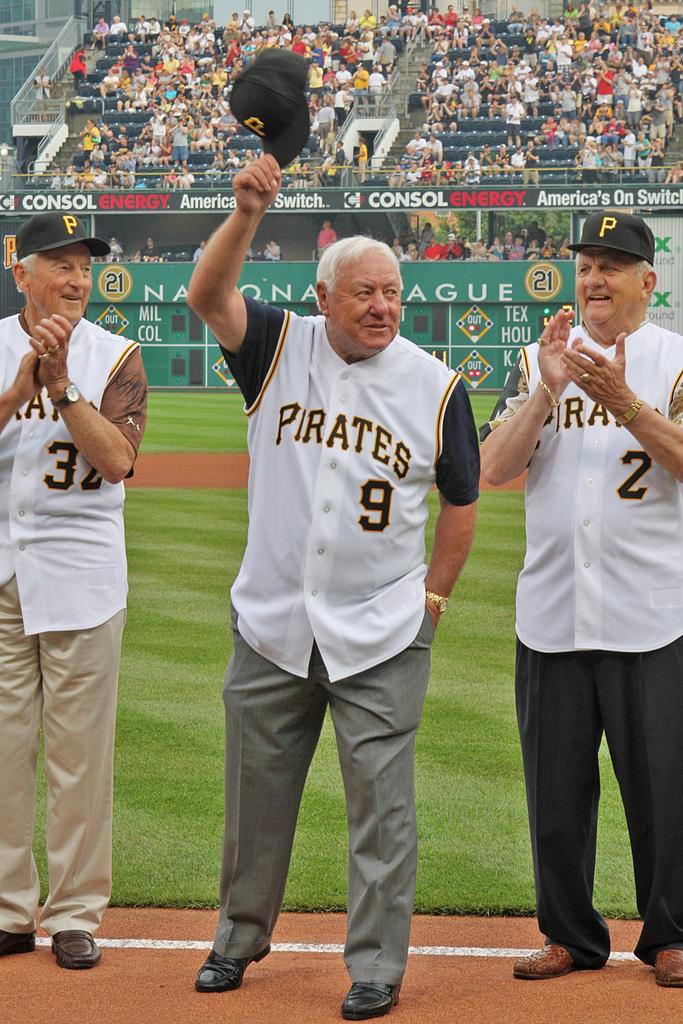What team is playing?
Provide a short and direct response. Pirates. What is the letter on the hat?
Your response must be concise. P. 